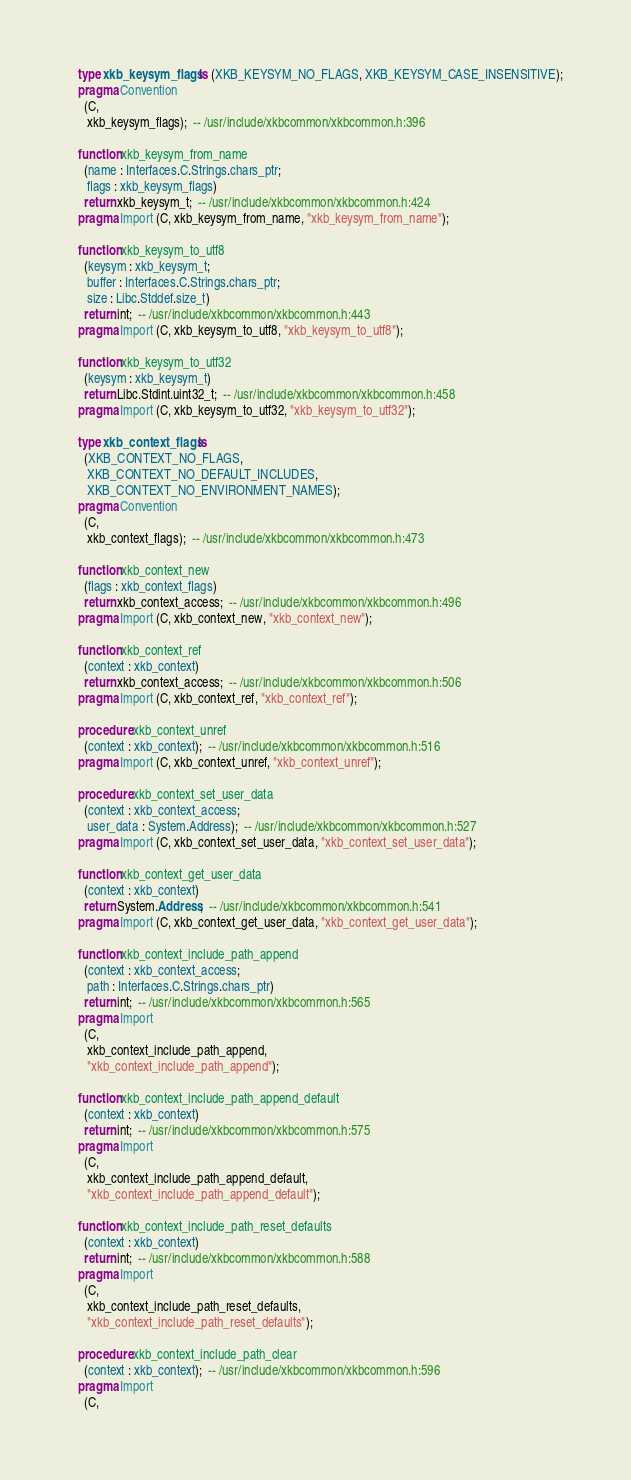Convert code to text. <code><loc_0><loc_0><loc_500><loc_500><_Ada_>   type xkb_keysym_flags is (XKB_KEYSYM_NO_FLAGS, XKB_KEYSYM_CASE_INSENSITIVE);
   pragma Convention
     (C,
      xkb_keysym_flags);  -- /usr/include/xkbcommon/xkbcommon.h:396

   function xkb_keysym_from_name
     (name : Interfaces.C.Strings.chars_ptr;
      flags : xkb_keysym_flags)
     return xkb_keysym_t;  -- /usr/include/xkbcommon/xkbcommon.h:424
   pragma Import (C, xkb_keysym_from_name, "xkb_keysym_from_name");

   function xkb_keysym_to_utf8
     (keysym : xkb_keysym_t;
      buffer : Interfaces.C.Strings.chars_ptr;
      size : Libc.Stddef.size_t)
     return int;  -- /usr/include/xkbcommon/xkbcommon.h:443
   pragma Import (C, xkb_keysym_to_utf8, "xkb_keysym_to_utf8");

   function xkb_keysym_to_utf32
     (keysym : xkb_keysym_t)
     return Libc.Stdint.uint32_t;  -- /usr/include/xkbcommon/xkbcommon.h:458
   pragma Import (C, xkb_keysym_to_utf32, "xkb_keysym_to_utf32");

   type xkb_context_flags is
     (XKB_CONTEXT_NO_FLAGS,
      XKB_CONTEXT_NO_DEFAULT_INCLUDES,
      XKB_CONTEXT_NO_ENVIRONMENT_NAMES);
   pragma Convention
     (C,
      xkb_context_flags);  -- /usr/include/xkbcommon/xkbcommon.h:473

   function xkb_context_new
     (flags : xkb_context_flags)
     return xkb_context_access;  -- /usr/include/xkbcommon/xkbcommon.h:496
   pragma Import (C, xkb_context_new, "xkb_context_new");

   function xkb_context_ref
     (context : xkb_context)
     return xkb_context_access;  -- /usr/include/xkbcommon/xkbcommon.h:506
   pragma Import (C, xkb_context_ref, "xkb_context_ref");

   procedure xkb_context_unref
     (context : xkb_context);  -- /usr/include/xkbcommon/xkbcommon.h:516
   pragma Import (C, xkb_context_unref, "xkb_context_unref");

   procedure xkb_context_set_user_data
     (context : xkb_context_access;
      user_data : System.Address);  -- /usr/include/xkbcommon/xkbcommon.h:527
   pragma Import (C, xkb_context_set_user_data, "xkb_context_set_user_data");

   function xkb_context_get_user_data
     (context : xkb_context)
     return System.Address;  -- /usr/include/xkbcommon/xkbcommon.h:541
   pragma Import (C, xkb_context_get_user_data, "xkb_context_get_user_data");

   function xkb_context_include_path_append
     (context : xkb_context_access;
      path : Interfaces.C.Strings.chars_ptr)
     return int;  -- /usr/include/xkbcommon/xkbcommon.h:565
   pragma Import
     (C,
      xkb_context_include_path_append,
      "xkb_context_include_path_append");

   function xkb_context_include_path_append_default
     (context : xkb_context)
     return int;  -- /usr/include/xkbcommon/xkbcommon.h:575
   pragma Import
     (C,
      xkb_context_include_path_append_default,
      "xkb_context_include_path_append_default");

   function xkb_context_include_path_reset_defaults
     (context : xkb_context)
     return int;  -- /usr/include/xkbcommon/xkbcommon.h:588
   pragma Import
     (C,
      xkb_context_include_path_reset_defaults,
      "xkb_context_include_path_reset_defaults");

   procedure xkb_context_include_path_clear
     (context : xkb_context);  -- /usr/include/xkbcommon/xkbcommon.h:596
   pragma Import
     (C,</code> 